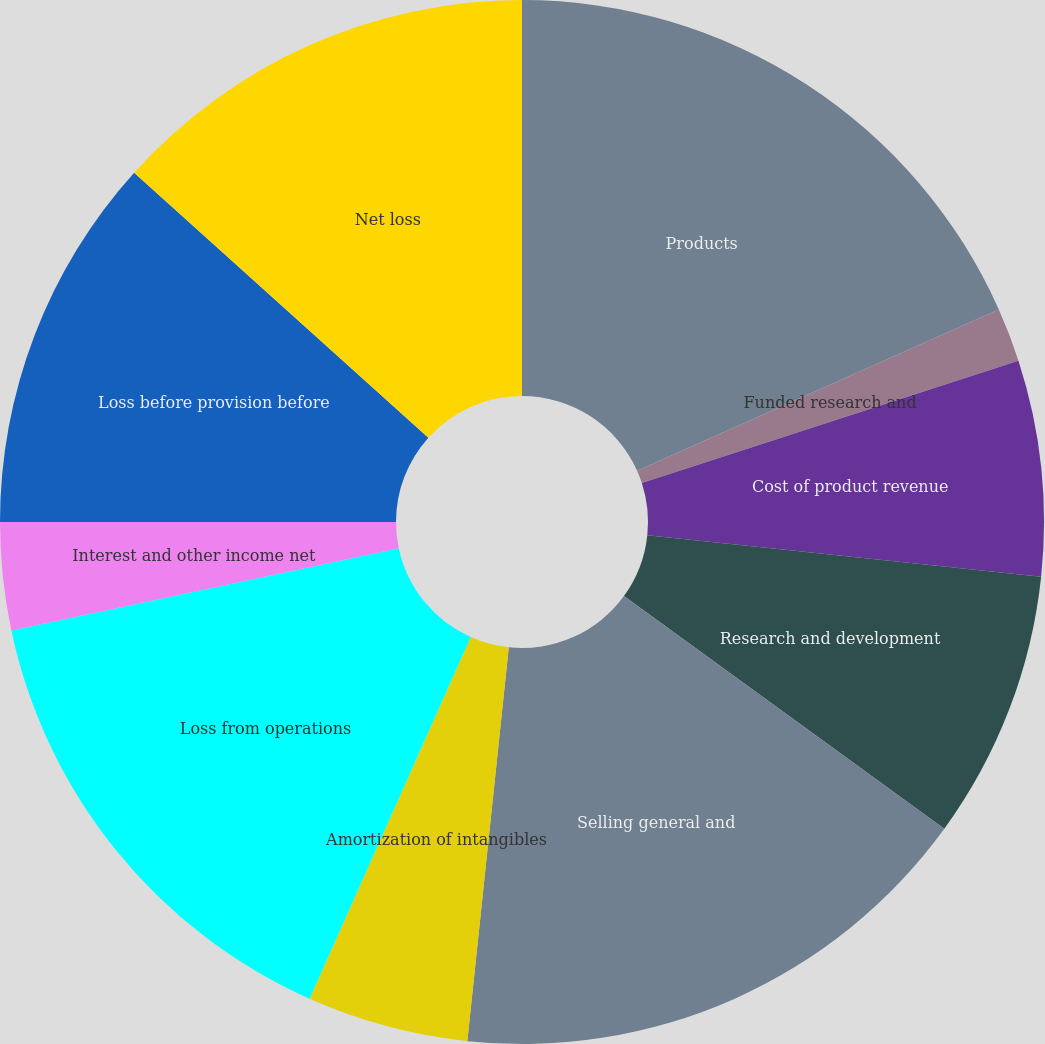Convert chart to OTSL. <chart><loc_0><loc_0><loc_500><loc_500><pie_chart><fcel>Products<fcel>Funded research and<fcel>Cost of product revenue<fcel>Research and development<fcel>Selling general and<fcel>Amortization of intangibles<fcel>Loss from operations<fcel>Interest and other income net<fcel>Loss before provision before<fcel>Net loss<nl><fcel>18.33%<fcel>1.67%<fcel>6.67%<fcel>8.33%<fcel>16.67%<fcel>5.0%<fcel>15.0%<fcel>3.33%<fcel>11.67%<fcel>13.33%<nl></chart> 